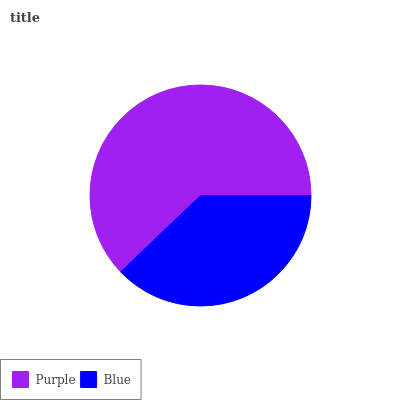Is Blue the minimum?
Answer yes or no. Yes. Is Purple the maximum?
Answer yes or no. Yes. Is Blue the maximum?
Answer yes or no. No. Is Purple greater than Blue?
Answer yes or no. Yes. Is Blue less than Purple?
Answer yes or no. Yes. Is Blue greater than Purple?
Answer yes or no. No. Is Purple less than Blue?
Answer yes or no. No. Is Purple the high median?
Answer yes or no. Yes. Is Blue the low median?
Answer yes or no. Yes. Is Blue the high median?
Answer yes or no. No. Is Purple the low median?
Answer yes or no. No. 